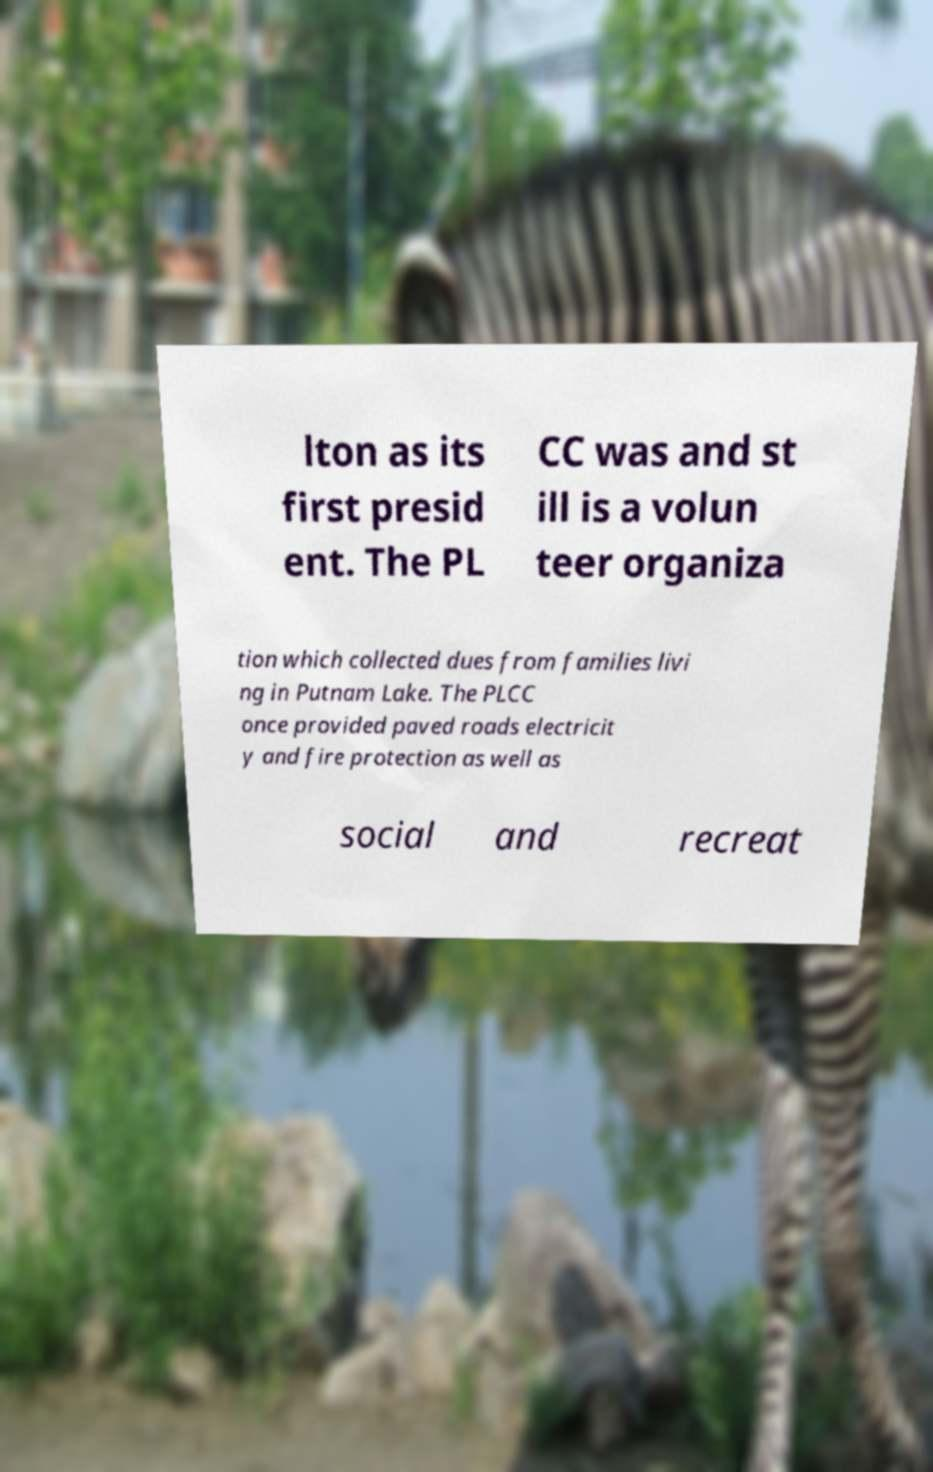Can you read and provide the text displayed in the image?This photo seems to have some interesting text. Can you extract and type it out for me? lton as its first presid ent. The PL CC was and st ill is a volun teer organiza tion which collected dues from families livi ng in Putnam Lake. The PLCC once provided paved roads electricit y and fire protection as well as social and recreat 